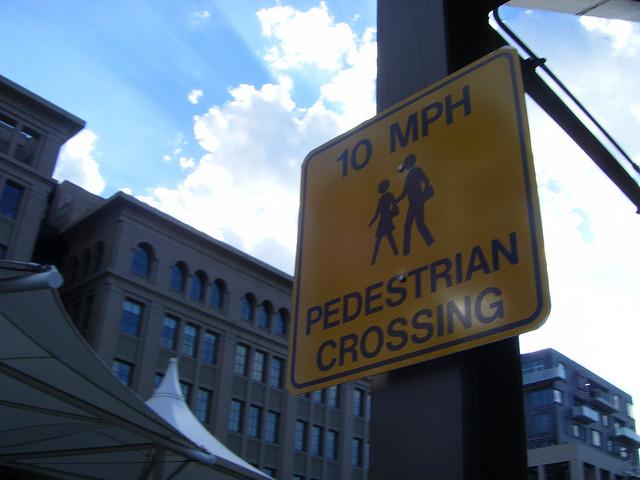What is the maximum speed allowed on this street?
Keep it brief. 10 mph. Is the sign yellow?
Give a very brief answer. Yes. What does the sign say?
Give a very brief answer. 10 mph pedestrian crossing. 